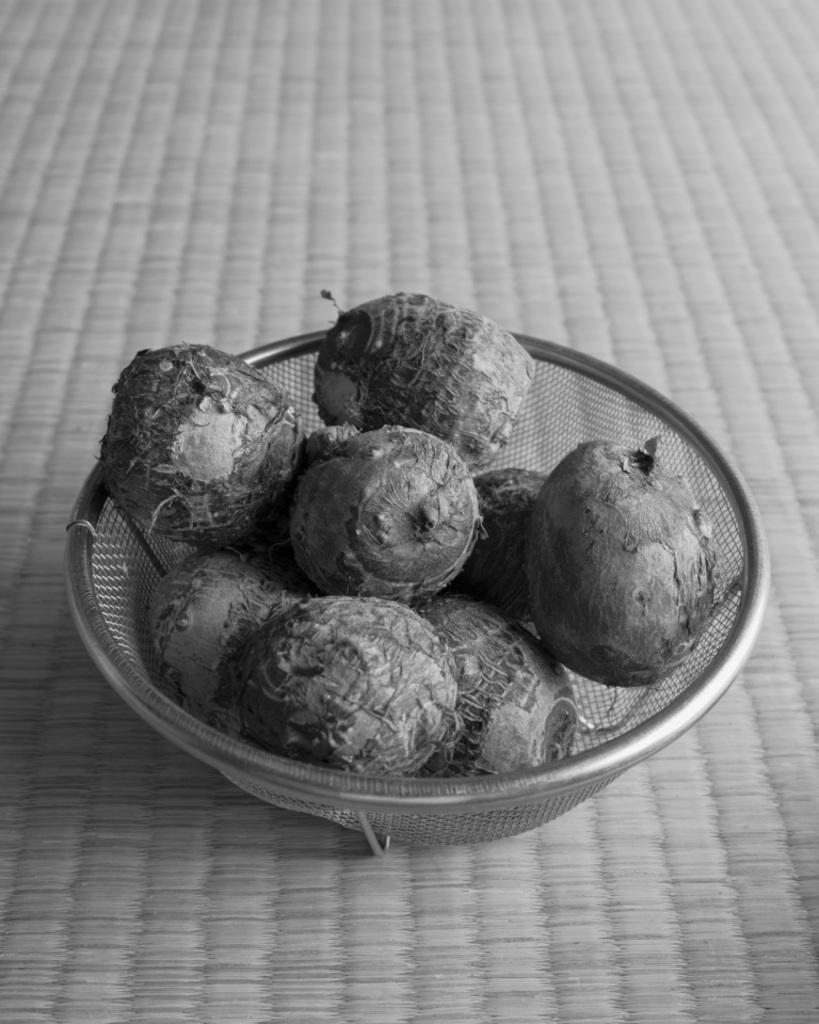Describe this image in one or two sentences. This is black and white image where we can see beetroot in a metal bowl. 